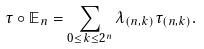<formula> <loc_0><loc_0><loc_500><loc_500>\tau \circ \mathbb { E } _ { n } = \sum _ { 0 \leq k \leq 2 ^ { n } } \lambda _ { ( n , k ) } \tau _ { ( n , k ) } .</formula> 